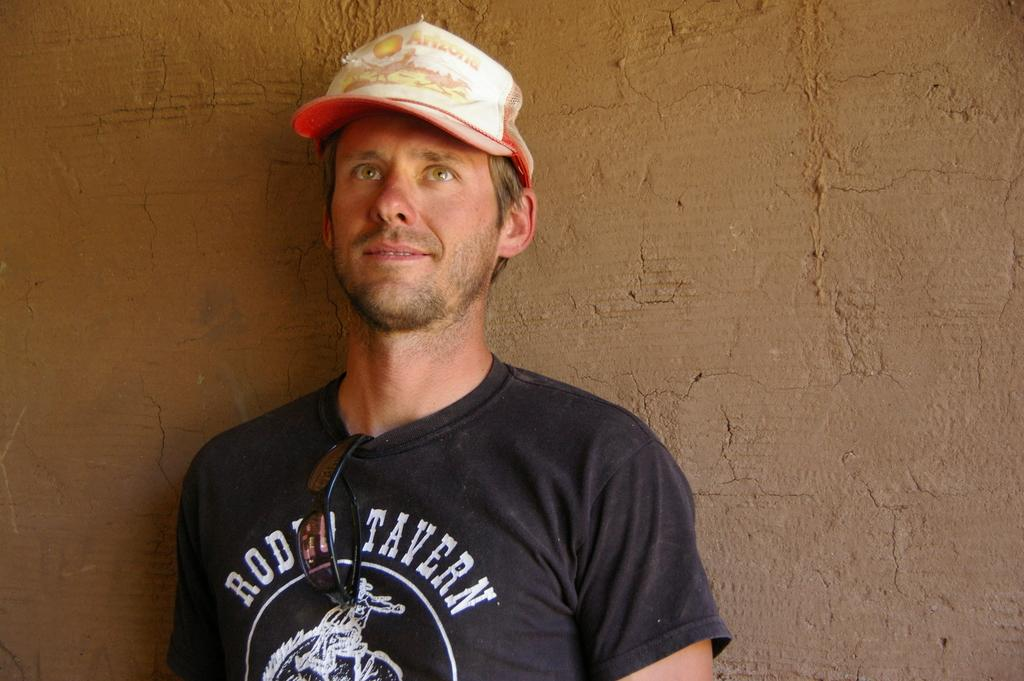<image>
Create a compact narrative representing the image presented. A man wears a black shirt that says RODEO TAVERN. 